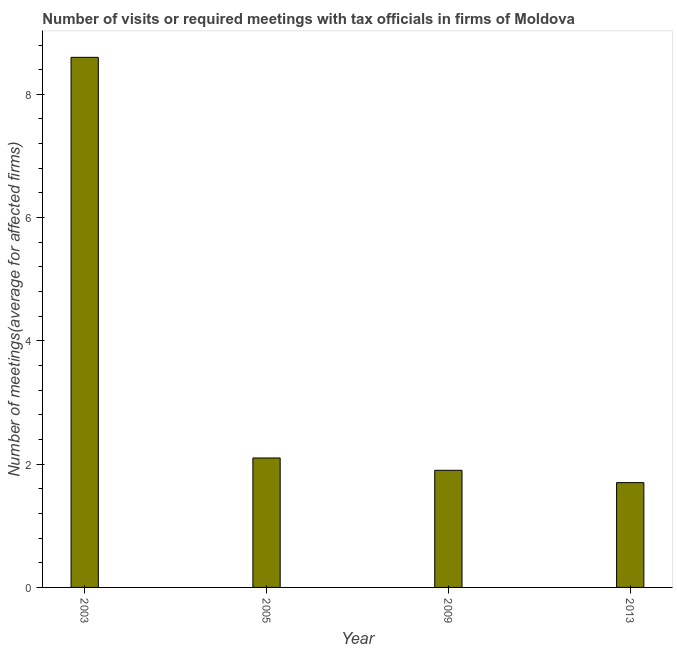What is the title of the graph?
Ensure brevity in your answer.  Number of visits or required meetings with tax officials in firms of Moldova. What is the label or title of the X-axis?
Your answer should be very brief. Year. What is the label or title of the Y-axis?
Your response must be concise. Number of meetings(average for affected firms). In which year was the number of required meetings with tax officials minimum?
Provide a short and direct response. 2013. What is the sum of the number of required meetings with tax officials?
Your response must be concise. 14.3. What is the average number of required meetings with tax officials per year?
Give a very brief answer. 3.58. What is the ratio of the number of required meetings with tax officials in 2003 to that in 2009?
Provide a short and direct response. 4.53. Is the number of required meetings with tax officials in 2005 less than that in 2013?
Ensure brevity in your answer.  No. Is the sum of the number of required meetings with tax officials in 2003 and 2005 greater than the maximum number of required meetings with tax officials across all years?
Your answer should be very brief. Yes. What is the difference between the highest and the lowest number of required meetings with tax officials?
Your answer should be compact. 6.9. In how many years, is the number of required meetings with tax officials greater than the average number of required meetings with tax officials taken over all years?
Provide a short and direct response. 1. Are the values on the major ticks of Y-axis written in scientific E-notation?
Give a very brief answer. No. What is the Number of meetings(average for affected firms) of 2003?
Provide a short and direct response. 8.6. What is the Number of meetings(average for affected firms) of 2009?
Your answer should be compact. 1.9. What is the difference between the Number of meetings(average for affected firms) in 2003 and 2005?
Provide a succinct answer. 6.5. What is the difference between the Number of meetings(average for affected firms) in 2003 and 2009?
Make the answer very short. 6.7. What is the difference between the Number of meetings(average for affected firms) in 2003 and 2013?
Give a very brief answer. 6.9. What is the difference between the Number of meetings(average for affected firms) in 2009 and 2013?
Provide a short and direct response. 0.2. What is the ratio of the Number of meetings(average for affected firms) in 2003 to that in 2005?
Provide a short and direct response. 4.09. What is the ratio of the Number of meetings(average for affected firms) in 2003 to that in 2009?
Keep it short and to the point. 4.53. What is the ratio of the Number of meetings(average for affected firms) in 2003 to that in 2013?
Give a very brief answer. 5.06. What is the ratio of the Number of meetings(average for affected firms) in 2005 to that in 2009?
Give a very brief answer. 1.1. What is the ratio of the Number of meetings(average for affected firms) in 2005 to that in 2013?
Ensure brevity in your answer.  1.24. What is the ratio of the Number of meetings(average for affected firms) in 2009 to that in 2013?
Your response must be concise. 1.12. 